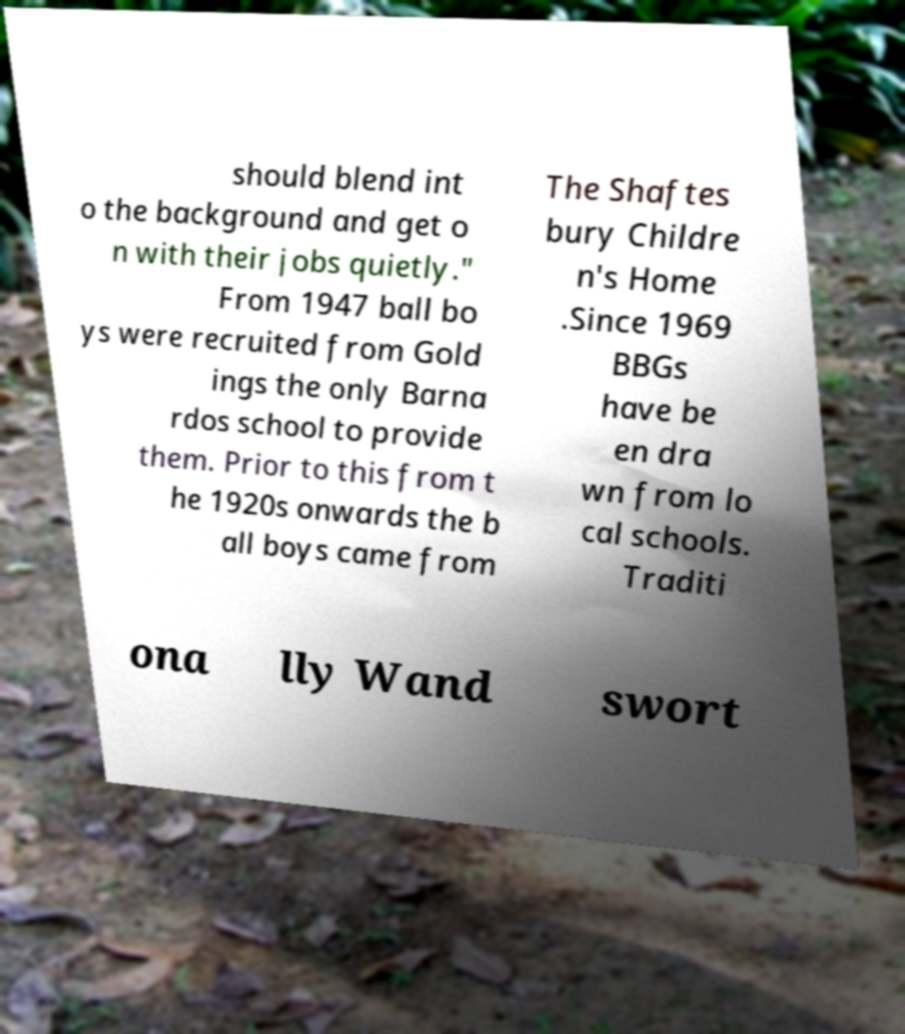Can you accurately transcribe the text from the provided image for me? should blend int o the background and get o n with their jobs quietly." From 1947 ball bo ys were recruited from Gold ings the only Barna rdos school to provide them. Prior to this from t he 1920s onwards the b all boys came from The Shaftes bury Childre n's Home .Since 1969 BBGs have be en dra wn from lo cal schools. Traditi ona lly Wand swort 